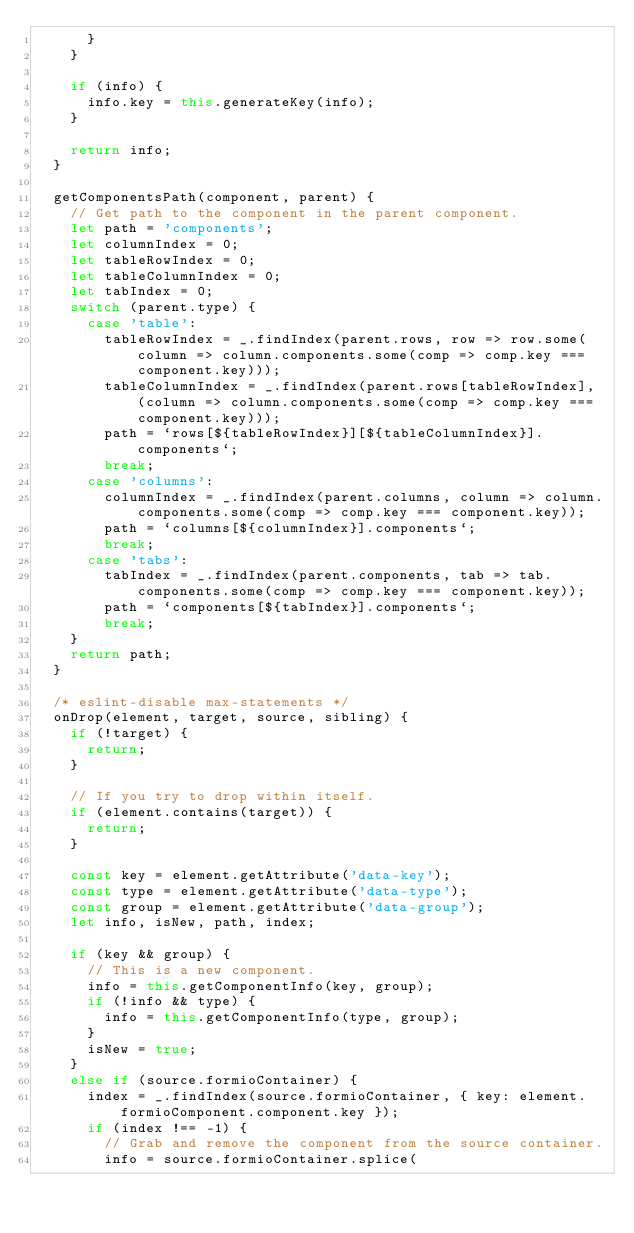Convert code to text. <code><loc_0><loc_0><loc_500><loc_500><_JavaScript_>      }
    }

    if (info) {
      info.key = this.generateKey(info);
    }

    return info;
  }

  getComponentsPath(component, parent) {
    // Get path to the component in the parent component.
    let path = 'components';
    let columnIndex = 0;
    let tableRowIndex = 0;
    let tableColumnIndex = 0;
    let tabIndex = 0;
    switch (parent.type) {
      case 'table':
        tableRowIndex = _.findIndex(parent.rows, row => row.some(column => column.components.some(comp => comp.key === component.key)));
        tableColumnIndex = _.findIndex(parent.rows[tableRowIndex], (column => column.components.some(comp => comp.key === component.key)));
        path = `rows[${tableRowIndex}][${tableColumnIndex}].components`;
        break;
      case 'columns':
        columnIndex = _.findIndex(parent.columns, column => column.components.some(comp => comp.key === component.key));
        path = `columns[${columnIndex}].components`;
        break;
      case 'tabs':
        tabIndex = _.findIndex(parent.components, tab => tab.components.some(comp => comp.key === component.key));
        path = `components[${tabIndex}].components`;
        break;
    }
    return path;
  }

  /* eslint-disable max-statements */
  onDrop(element, target, source, sibling) {
    if (!target) {
      return;
    }

    // If you try to drop within itself.
    if (element.contains(target)) {
      return;
    }

    const key = element.getAttribute('data-key');
    const type = element.getAttribute('data-type');
    const group = element.getAttribute('data-group');
    let info, isNew, path, index;

    if (key && group) {
      // This is a new component.
      info = this.getComponentInfo(key, group);
      if (!info && type) {
        info = this.getComponentInfo(type, group);
      }
      isNew = true;
    }
    else if (source.formioContainer) {
      index = _.findIndex(source.formioContainer, { key: element.formioComponent.component.key });
      if (index !== -1) {
        // Grab and remove the component from the source container.
        info = source.formioContainer.splice(</code> 